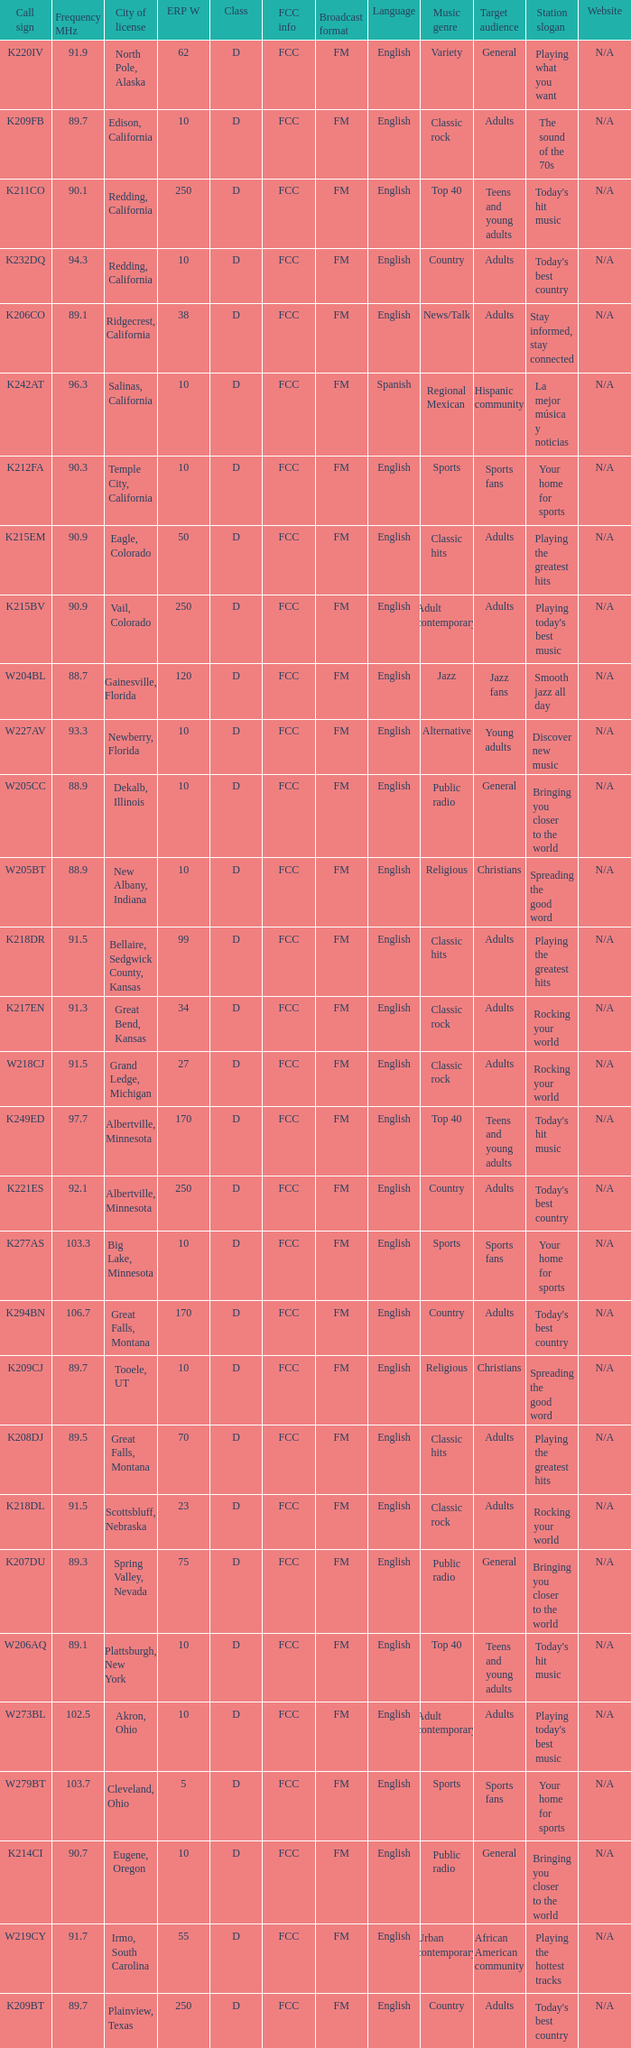What is the highest ERP W of an 89.1 frequency translator? 38.0. 